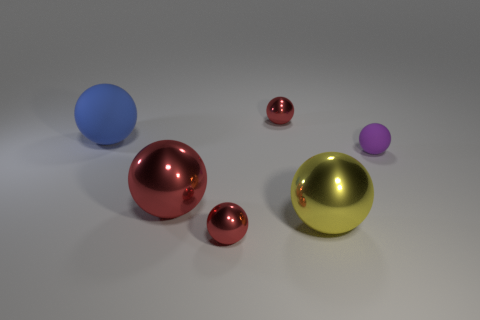Is the small purple rubber thing the same shape as the yellow shiny thing?
Your response must be concise. Yes. Do the blue sphere and the sphere that is right of the large yellow metallic thing have the same size?
Your answer should be very brief. No. What is the color of the tiny shiny object that is behind the tiny red object in front of the blue matte thing?
Ensure brevity in your answer.  Red. What is the size of the yellow ball?
Give a very brief answer. Large. Is the number of red spheres that are behind the blue matte thing greater than the number of matte spheres in front of the big yellow metal ball?
Your answer should be very brief. Yes. How many big objects are left of the small metal sphere in front of the tiny purple rubber ball?
Ensure brevity in your answer.  2. There is a object on the right side of the big yellow shiny ball; is its shape the same as the blue object?
Your response must be concise. Yes. What is the material of the blue object that is the same shape as the small purple rubber object?
Give a very brief answer. Rubber. What number of yellow metal spheres have the same size as the purple object?
Offer a terse response. 0. What color is the small thing that is behind the large red metal sphere and in front of the large matte object?
Provide a succinct answer. Purple. 